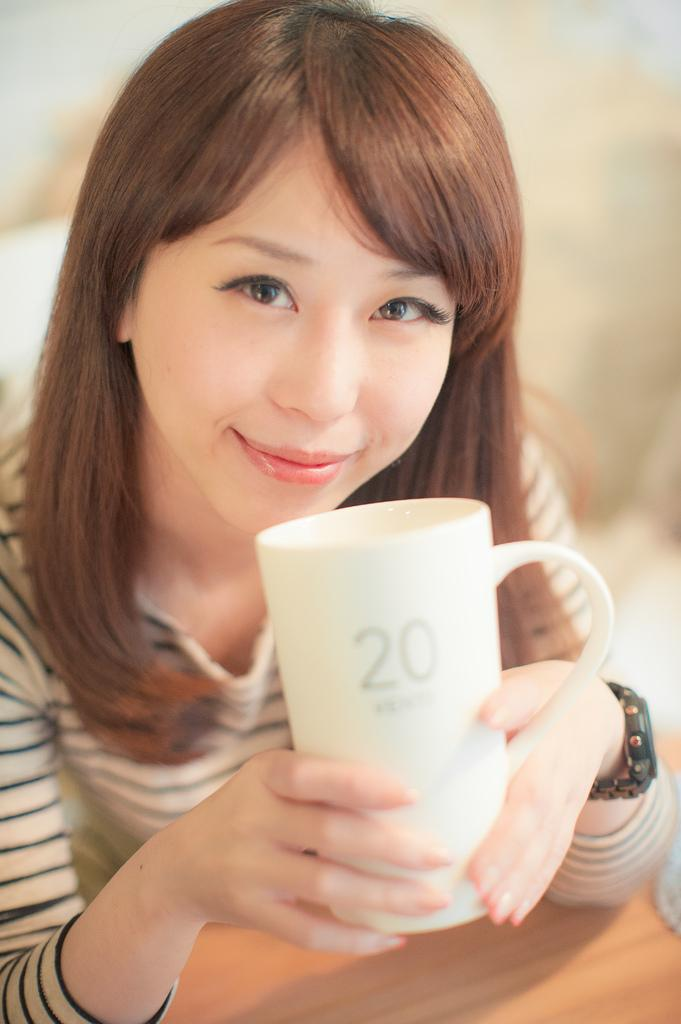What is the person in the image doing? There is a person sitting in the image. What is the person holding in the image? The person is holding a cup. Where is the airport located in the image? There is no airport present in the image. What type of scale is visible in the image? There is no scale present in the image. 